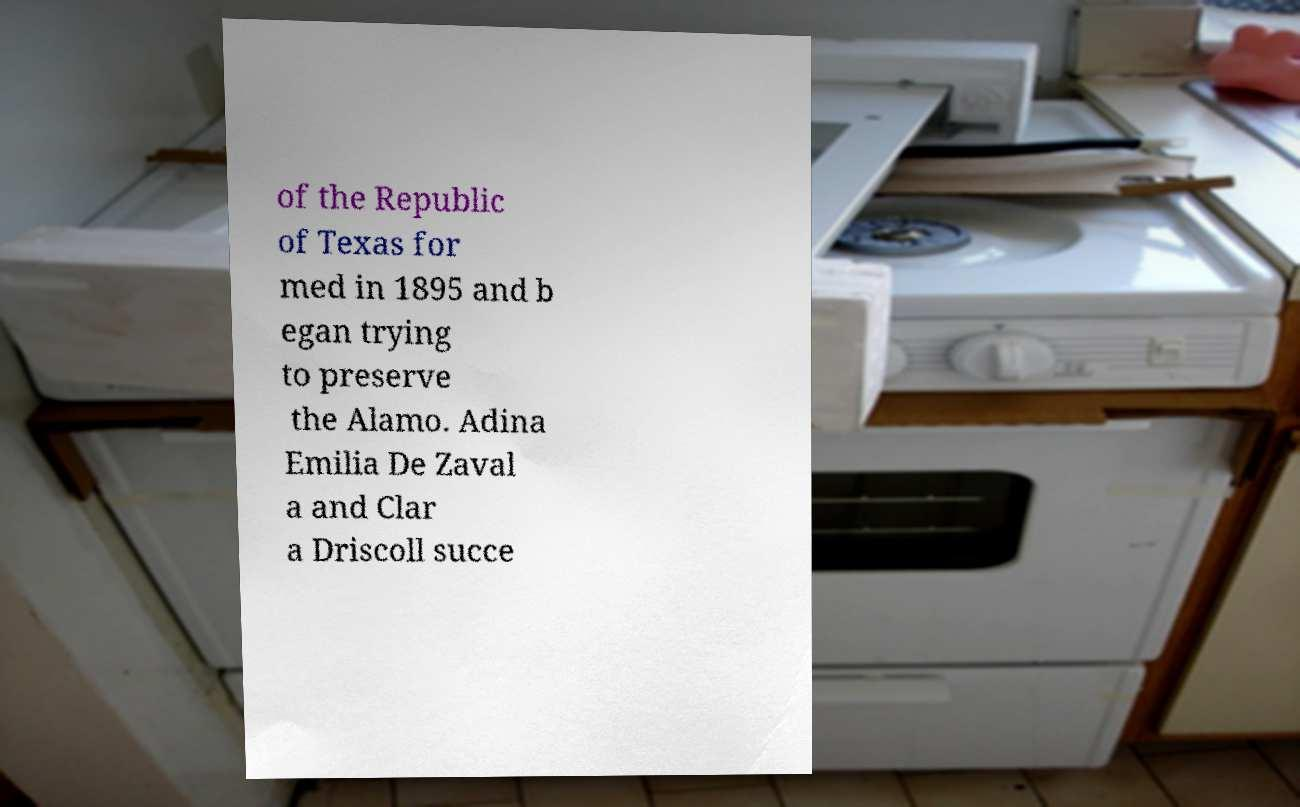Please identify and transcribe the text found in this image. of the Republic of Texas for med in 1895 and b egan trying to preserve the Alamo. Adina Emilia De Zaval a and Clar a Driscoll succe 